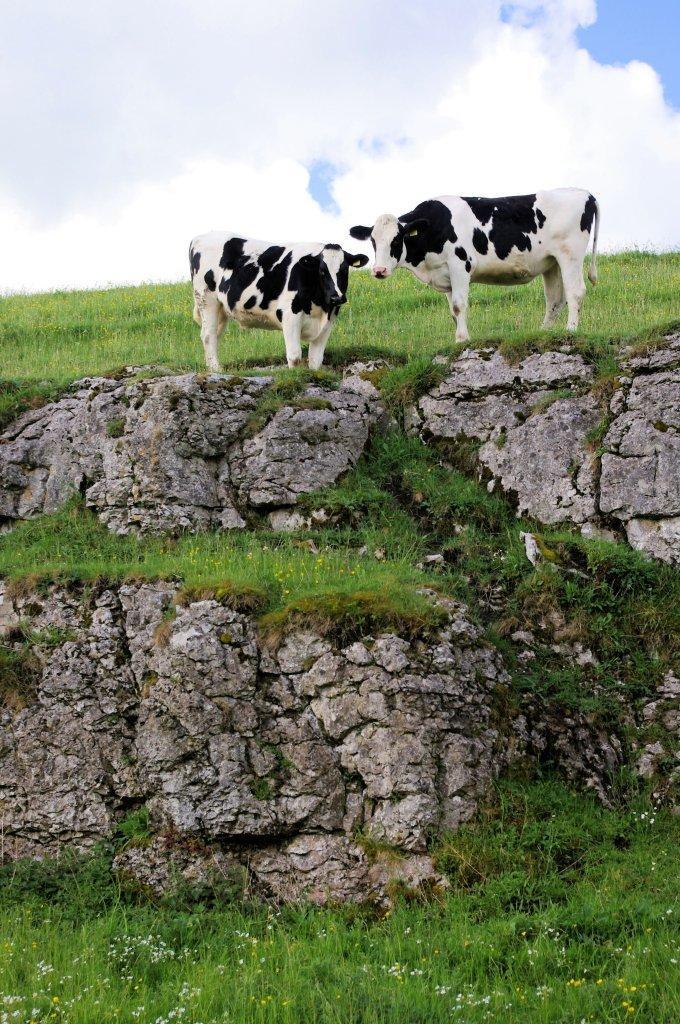In one or two sentences, can you explain what this image depicts? In the image I can see two cows are standing on the ground. In the background I can see the grass and the sky. 